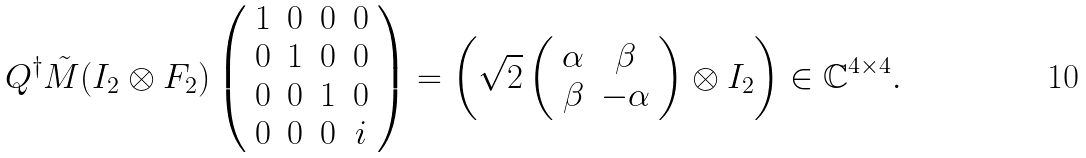Convert formula to latex. <formula><loc_0><loc_0><loc_500><loc_500>Q ^ { \dagger } { \tilde { M } } ( I _ { 2 } \otimes F _ { 2 } ) \left ( \begin{array} { c c c c } 1 & 0 & 0 & 0 \\ 0 & 1 & 0 & 0 \\ 0 & 0 & 1 & 0 \\ 0 & 0 & 0 & i \end{array} \right ) = \left ( \sqrt { 2 } \left ( \begin{array} { c c } \alpha & \beta \\ \beta & - \alpha \end{array} \right ) \otimes I _ { 2 } \right ) \in { \mathbb { C } } ^ { 4 \times 4 } .</formula> 